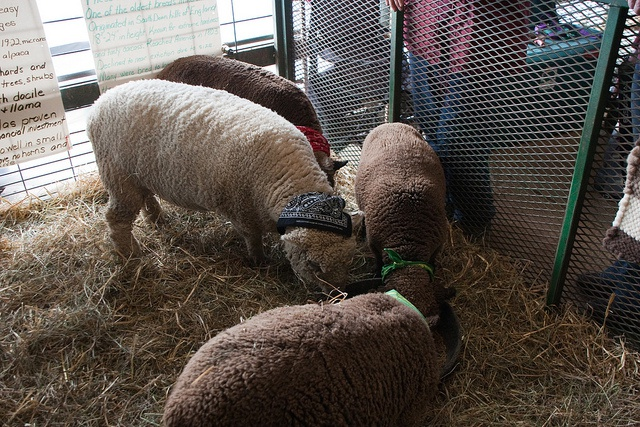Describe the objects in this image and their specific colors. I can see sheep in lightgray, gray, and black tones, sheep in lightgray, black, gray, and darkgray tones, people in lightgray, black, gray, darkgray, and maroon tones, sheep in lightgray, black, gray, and darkgray tones, and sheep in lightgray, black, maroon, gray, and darkgray tones in this image. 